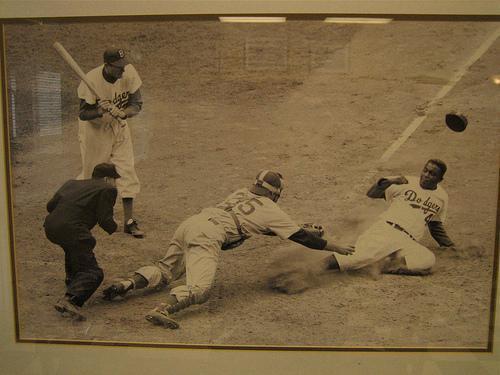How many umpires are there?
Give a very brief answer. 1. 